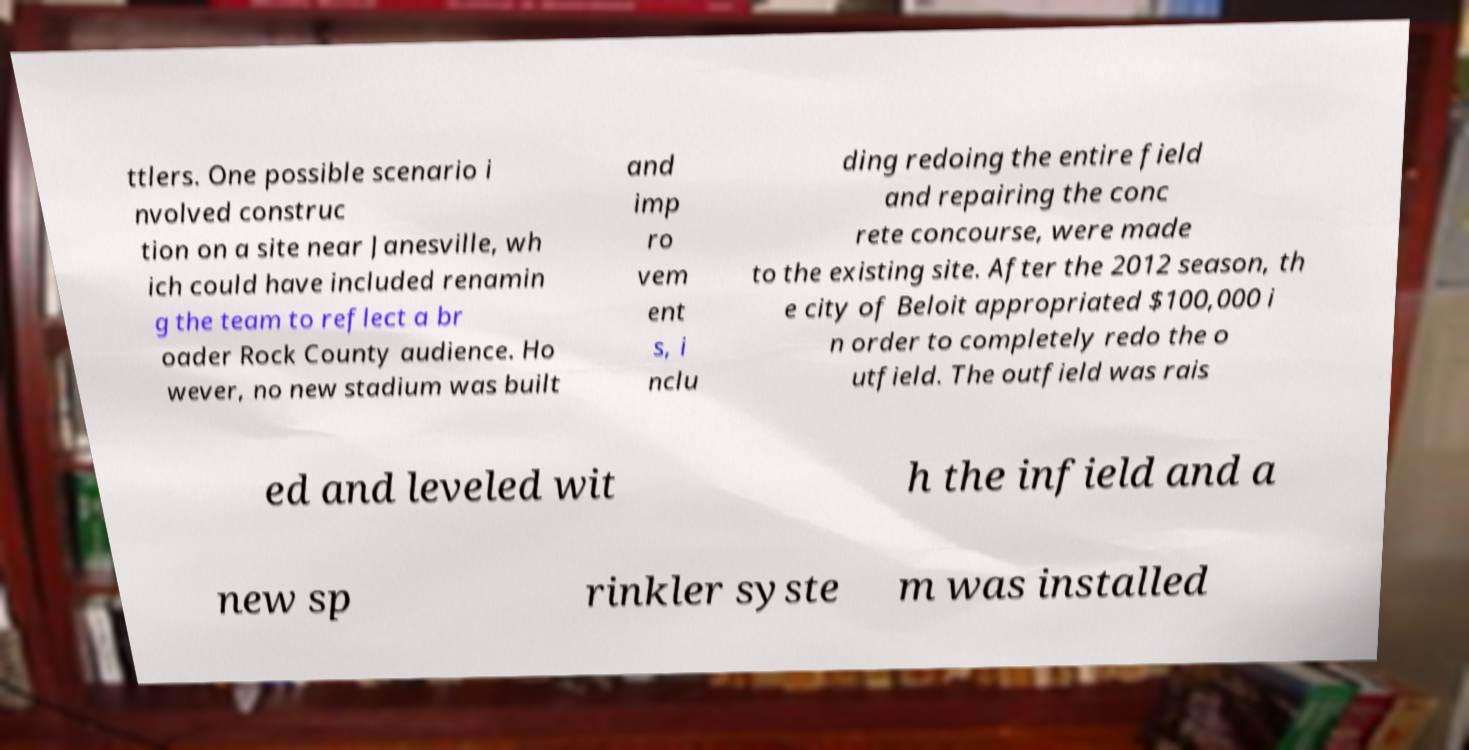Please identify and transcribe the text found in this image. ttlers. One possible scenario i nvolved construc tion on a site near Janesville, wh ich could have included renamin g the team to reflect a br oader Rock County audience. Ho wever, no new stadium was built and imp ro vem ent s, i nclu ding redoing the entire field and repairing the conc rete concourse, were made to the existing site. After the 2012 season, th e city of Beloit appropriated $100,000 i n order to completely redo the o utfield. The outfield was rais ed and leveled wit h the infield and a new sp rinkler syste m was installed 